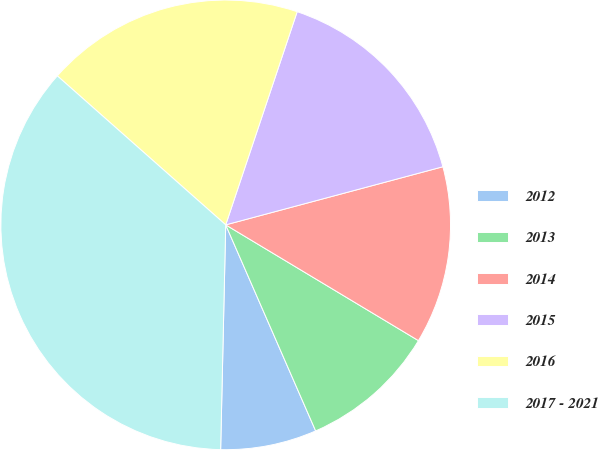Convert chart to OTSL. <chart><loc_0><loc_0><loc_500><loc_500><pie_chart><fcel>2012<fcel>2013<fcel>2014<fcel>2015<fcel>2016<fcel>2017 - 2021<nl><fcel>6.91%<fcel>9.84%<fcel>12.77%<fcel>15.69%<fcel>18.62%<fcel>36.17%<nl></chart> 